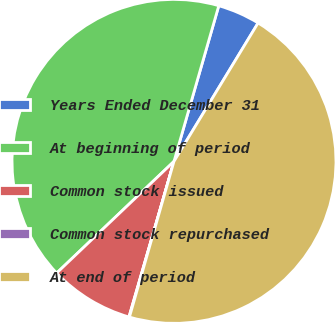Convert chart to OTSL. <chart><loc_0><loc_0><loc_500><loc_500><pie_chart><fcel>Years Ended December 31<fcel>At beginning of period<fcel>Common stock issued<fcel>Common stock repurchased<fcel>At end of period<nl><fcel>4.23%<fcel>41.57%<fcel>8.41%<fcel>0.05%<fcel>45.75%<nl></chart> 